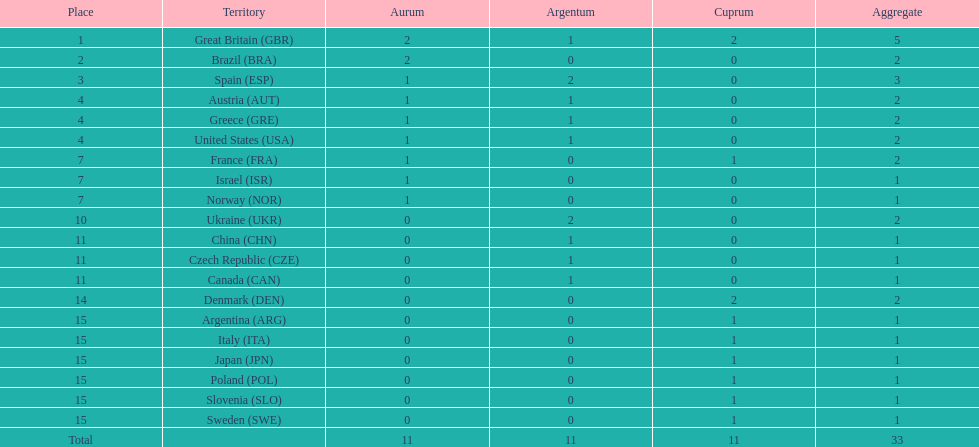Who won more gold medals than spain? Great Britain (GBR), Brazil (BRA). 